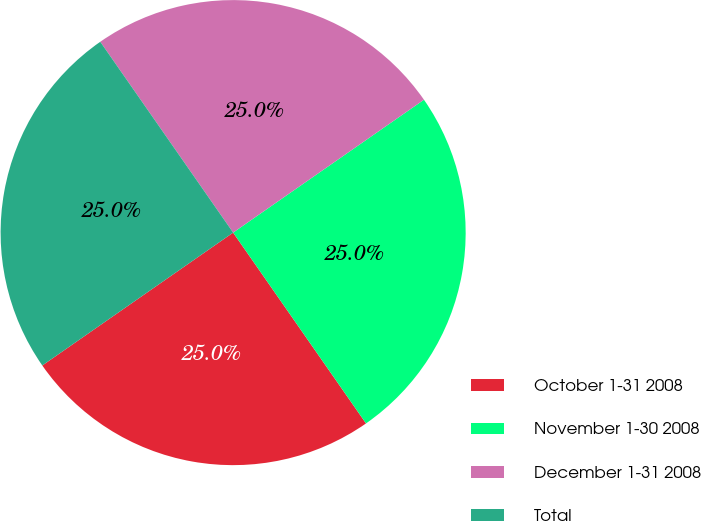Convert chart. <chart><loc_0><loc_0><loc_500><loc_500><pie_chart><fcel>October 1-31 2008<fcel>November 1-30 2008<fcel>December 1-31 2008<fcel>Total<nl><fcel>25.0%<fcel>25.0%<fcel>25.0%<fcel>25.0%<nl></chart> 